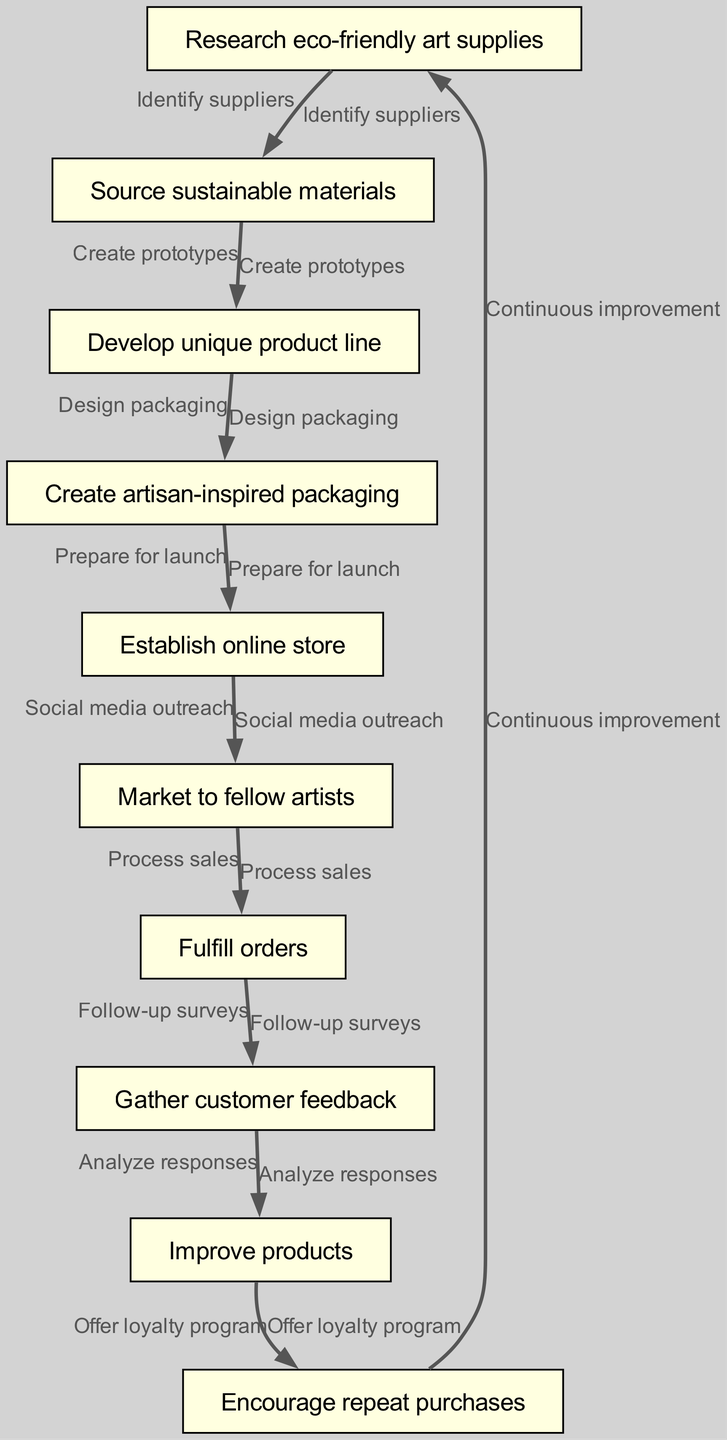What is the first step in the lifecycle of the art supplies business? The first step is represented by the node labeled "Research eco-friendly art supplies." It is the starting point of the flow chart, indicating the initial action in this business lifecycle.
Answer: Research eco-friendly art supplies How many nodes are present in the diagram? By counting each unique node in the diagram, we find there are a total of 10 nodes listed. This includes each distinct step from the beginning to the end of the lifecycle.
Answer: 10 What type of packaging is developed in the process? The diagram indicates that the packaging created is "artisan-inspired packaging." This shows the focus on aesthetics that align with the artisan theme of the product line.
Answer: Artisan-inspired packaging Which step involves gathering customer feedback? The step that involves gathering customer feedback is labeled as "Gather customer feedback." It is positioned in the sequence after order fulfillment.
Answer: Gather customer feedback What is the relationship between "Develop unique product line" and "Create artisan-inspired packaging"? The relationship is that the "Develop unique product line" step leads to the design of "Create artisan-inspired packaging." This sequential connection shows that the packaging design is based on the unique products developed earlier in the process.
Answer: Design packaging What is offered to encourage repeat purchases? The diagram specifies that a "loyalty program" is offered to encourage repeat purchases. This strategy aims to enhance customer retention and satisfaction.
Answer: Loyalty program What action is taken after fulfilling orders? After fulfilling orders, the next action taken is to "Gather customer feedback." This step is crucial for understanding customer satisfaction and potential improvements.
Answer: Gather customer feedback How does the diagram indicate continuous improvement? The flow chart illustrates that "Continuous improvement" is achieved through a feedback loop that starts again with "Research eco-friendly art supplies," emphasizing an ongoing cycle of enhancement based on customer insights.
Answer: Continuous improvement What is the step before establishing an online store? Before establishing an online store, the diagram shows the step "Create artisan-inspired packaging." This order indicates the preparation needed for the online presence to match the product aesthetic.
Answer: Create artisan-inspired packaging 